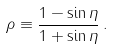<formula> <loc_0><loc_0><loc_500><loc_500>\rho \equiv \frac { 1 - \sin \eta } { 1 + \sin \eta } \, .</formula> 